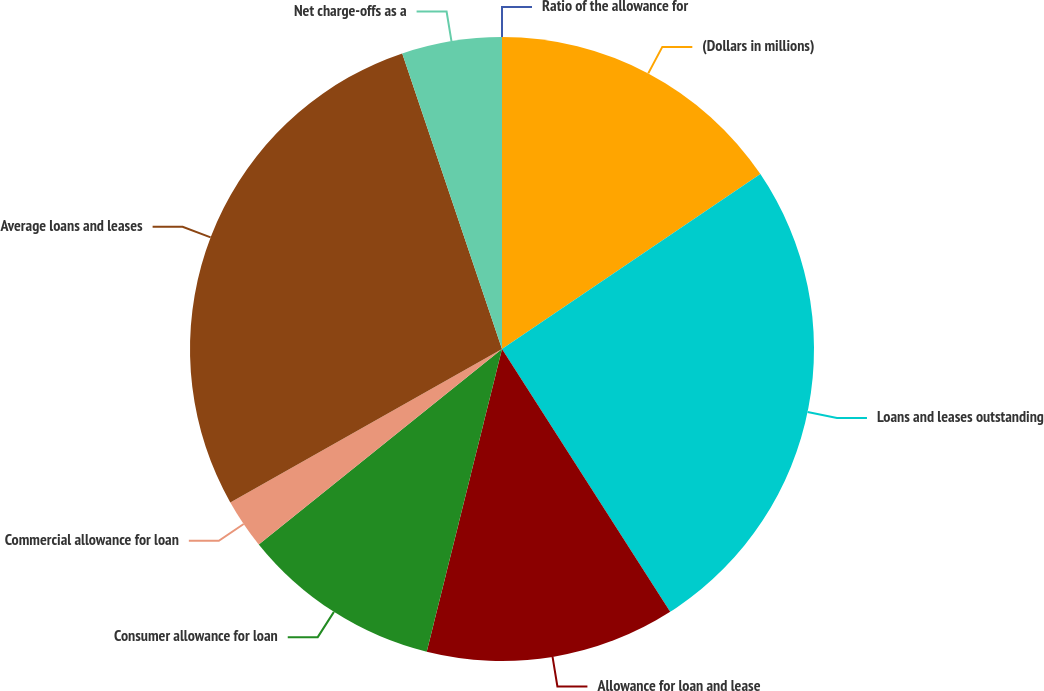<chart> <loc_0><loc_0><loc_500><loc_500><pie_chart><fcel>(Dollars in millions)<fcel>Loans and leases outstanding<fcel>Allowance for loan and lease<fcel>Consumer allowance for loan<fcel>Commercial allowance for loan<fcel>Average loans and leases<fcel>Net charge-offs as a<fcel>Ratio of the allowance for<nl><fcel>15.53%<fcel>25.41%<fcel>12.94%<fcel>10.35%<fcel>2.59%<fcel>28.0%<fcel>5.18%<fcel>0.0%<nl></chart> 